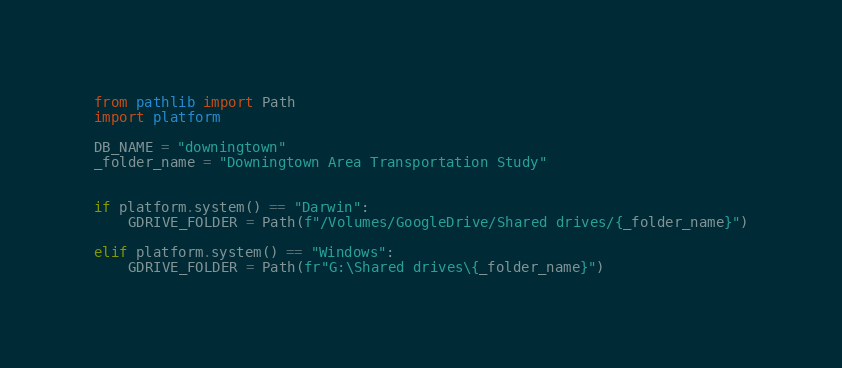<code> <loc_0><loc_0><loc_500><loc_500><_Python_>from pathlib import Path
import platform

DB_NAME = "downingtown"
_folder_name = "Downingtown Area Transportation Study"


if platform.system() == "Darwin":
    GDRIVE_FOLDER = Path(f"/Volumes/GoogleDrive/Shared drives/{_folder_name}")

elif platform.system() == "Windows":
    GDRIVE_FOLDER = Path(fr"G:\Shared drives\{_folder_name}")
</code> 